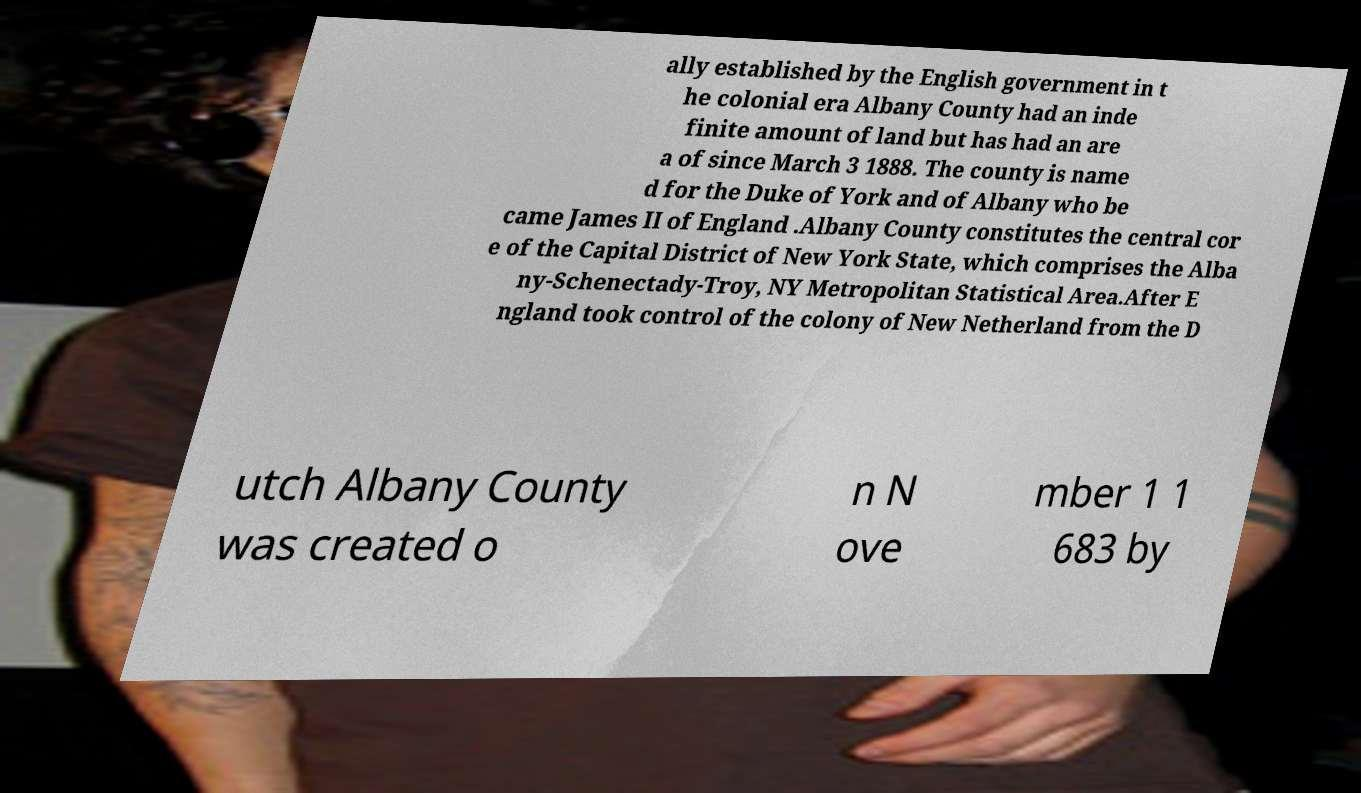Please identify and transcribe the text found in this image. ally established by the English government in t he colonial era Albany County had an inde finite amount of land but has had an are a of since March 3 1888. The county is name d for the Duke of York and of Albany who be came James II of England .Albany County constitutes the central cor e of the Capital District of New York State, which comprises the Alba ny-Schenectady-Troy, NY Metropolitan Statistical Area.After E ngland took control of the colony of New Netherland from the D utch Albany County was created o n N ove mber 1 1 683 by 